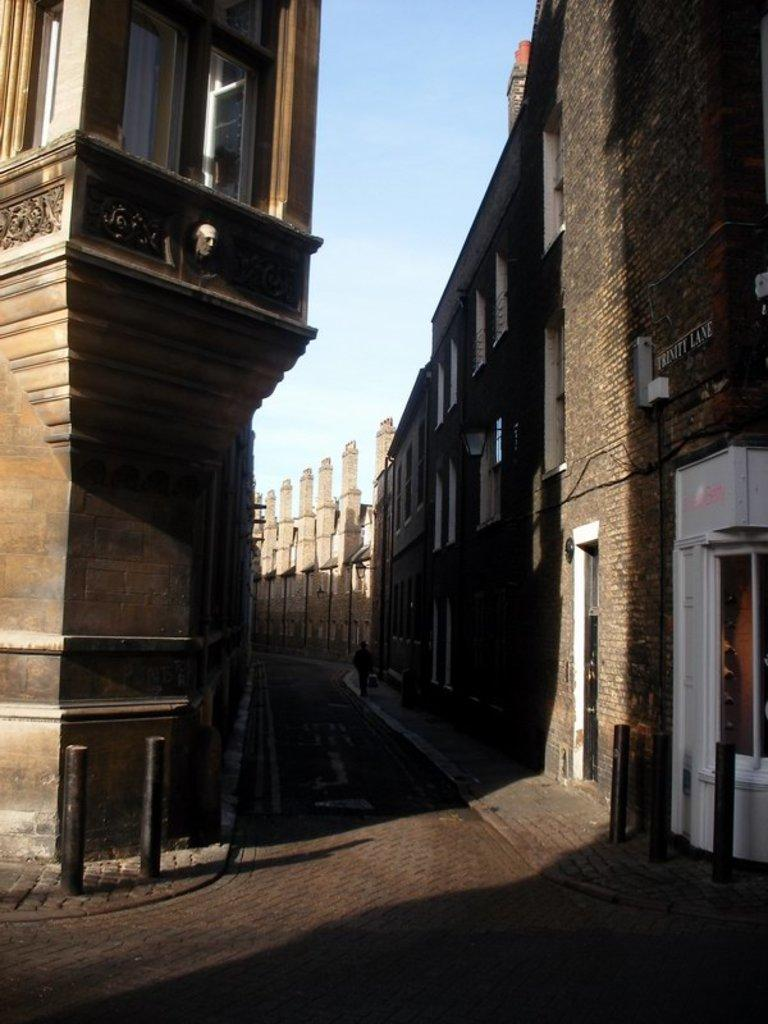What is the main feature of the image? There is a road in the image. How is the road positioned in relation to other structures? The road is situated between buildings. What type of beef can be seen hanging from a line in the image? There is no beef or line present in the image; it only features a road and buildings. 